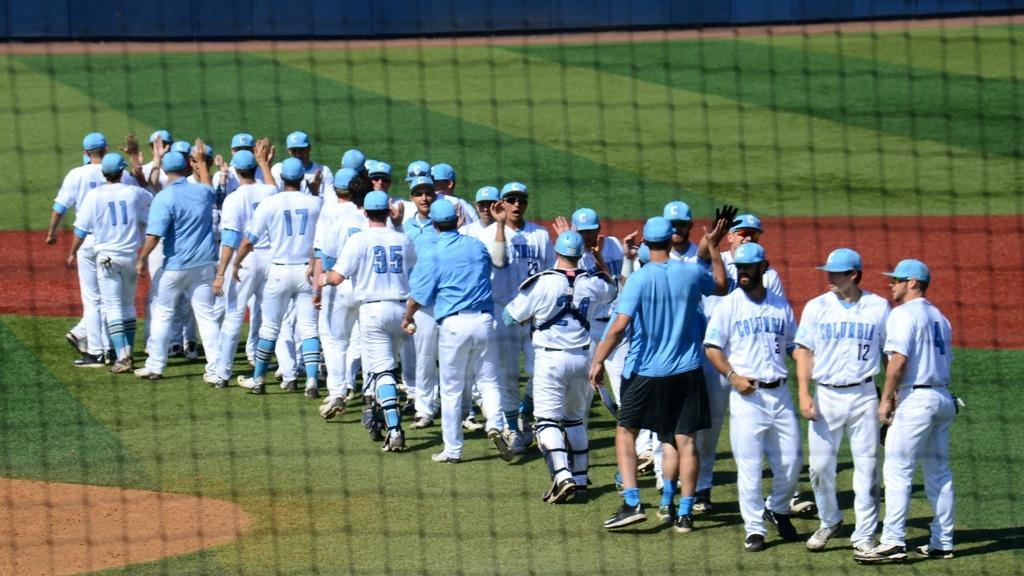<image>
Share a concise interpretation of the image provided. A team of baseball players on a field with the name Columbia written on the shirt. 